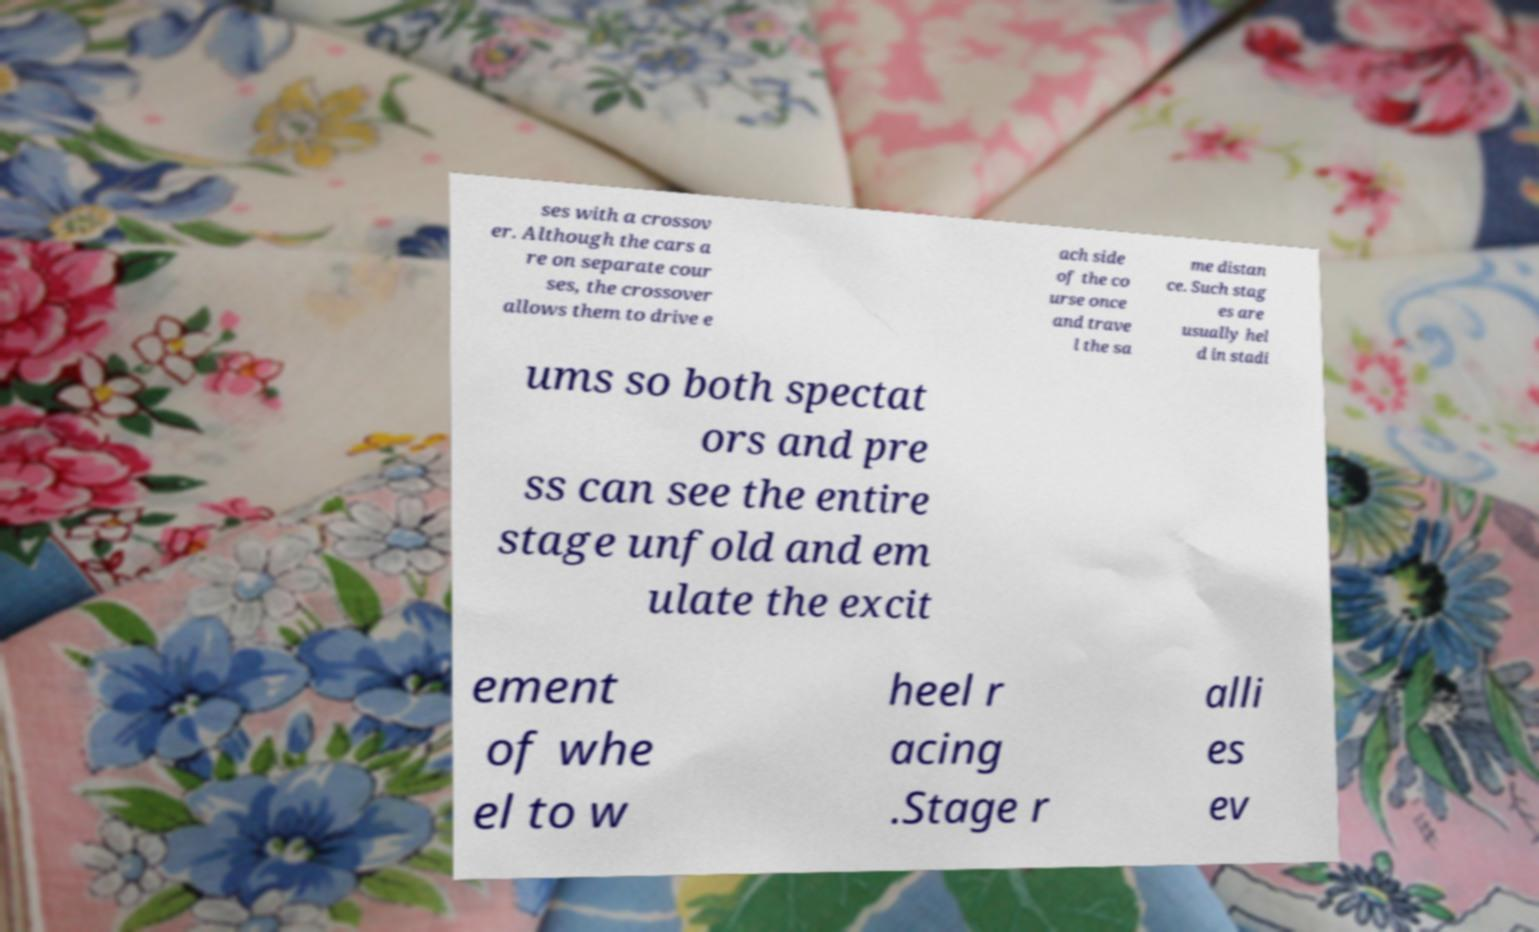What messages or text are displayed in this image? I need them in a readable, typed format. ses with a crossov er. Although the cars a re on separate cour ses, the crossover allows them to drive e ach side of the co urse once and trave l the sa me distan ce. Such stag es are usually hel d in stadi ums so both spectat ors and pre ss can see the entire stage unfold and em ulate the excit ement of whe el to w heel r acing .Stage r alli es ev 